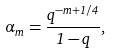<formula> <loc_0><loc_0><loc_500><loc_500>\alpha _ { m } = \frac { q ^ { - m + 1 / 4 } } { 1 - q } ,</formula> 